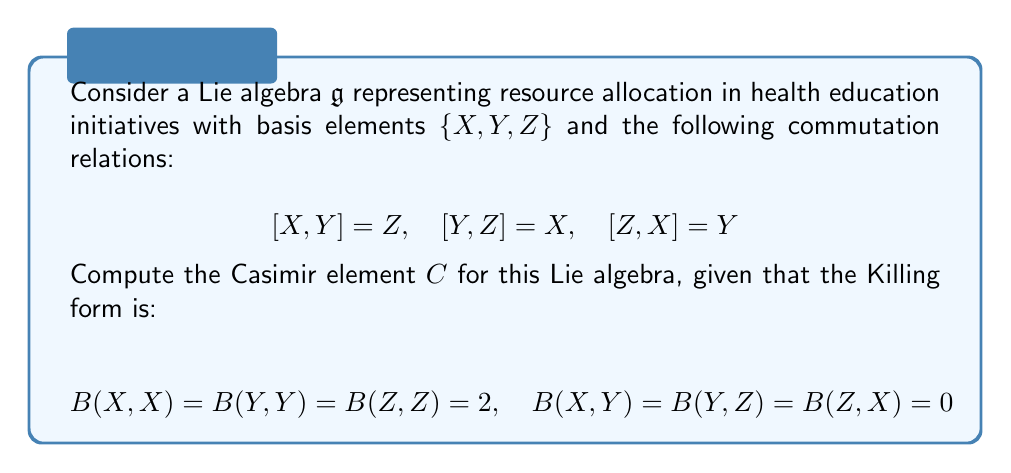Could you help me with this problem? To compute the Casimir element for this Lie algebra, we follow these steps:

1) The Casimir element is defined as $C = \sum_{i,j} B^{ij} e_i e_j$, where $B^{ij}$ is the inverse of the matrix representation of the Killing form, and $e_i$ are the basis elements.

2) First, let's write the matrix representation of the Killing form:

   $$B = \begin{pmatrix}
   2 & 0 & 0 \\
   0 & 2 & 0 \\
   0 & 0 & 2
   \end{pmatrix}$$

3) The inverse of this matrix is:

   $$B^{-1} = \begin{pmatrix}
   1/2 & 0 & 0 \\
   0 & 1/2 & 0 \\
   0 & 0 & 1/2
   \end{pmatrix}$$

4) Now, we can compute the Casimir element:

   $$\begin{align}
   C &= \sum_{i,j} B^{ij} e_i e_j \\
   &= \frac{1}{2}X^2 + \frac{1}{2}Y^2 + \frac{1}{2}Z^2
   \end{align}$$

5) This can be written more compactly as:

   $$C = \frac{1}{2}(X^2 + Y^2 + Z^2)$$

This Casimir element represents a quadratic invariant of the Lie algebra, which in the context of resource allocation for health education initiatives, could be interpreted as a measure of the total resources available or the overall efficiency of the allocation strategy.
Answer: $$C = \frac{1}{2}(X^2 + Y^2 + Z^2)$$ 